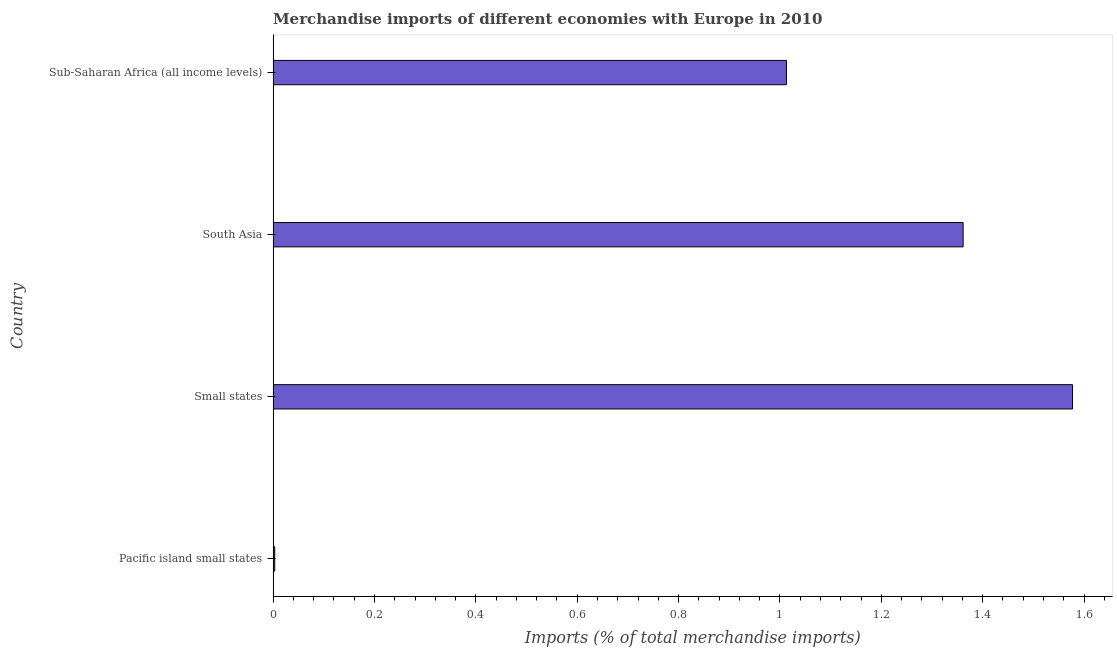Does the graph contain grids?
Make the answer very short. No. What is the title of the graph?
Make the answer very short. Merchandise imports of different economies with Europe in 2010. What is the label or title of the X-axis?
Give a very brief answer. Imports (% of total merchandise imports). What is the merchandise imports in Pacific island small states?
Offer a terse response. 0. Across all countries, what is the maximum merchandise imports?
Your response must be concise. 1.58. Across all countries, what is the minimum merchandise imports?
Offer a terse response. 0. In which country was the merchandise imports maximum?
Ensure brevity in your answer.  Small states. In which country was the merchandise imports minimum?
Offer a terse response. Pacific island small states. What is the sum of the merchandise imports?
Give a very brief answer. 3.95. What is the difference between the merchandise imports in Pacific island small states and South Asia?
Your response must be concise. -1.36. What is the median merchandise imports?
Give a very brief answer. 1.19. What is the ratio of the merchandise imports in Pacific island small states to that in Sub-Saharan Africa (all income levels)?
Make the answer very short. 0. Is the merchandise imports in Pacific island small states less than that in Sub-Saharan Africa (all income levels)?
Keep it short and to the point. Yes. What is the difference between the highest and the second highest merchandise imports?
Ensure brevity in your answer.  0.22. Is the sum of the merchandise imports in Small states and South Asia greater than the maximum merchandise imports across all countries?
Offer a terse response. Yes. What is the difference between the highest and the lowest merchandise imports?
Provide a short and direct response. 1.57. In how many countries, is the merchandise imports greater than the average merchandise imports taken over all countries?
Your answer should be very brief. 3. How many bars are there?
Provide a short and direct response. 4. What is the difference between two consecutive major ticks on the X-axis?
Make the answer very short. 0.2. Are the values on the major ticks of X-axis written in scientific E-notation?
Make the answer very short. No. What is the Imports (% of total merchandise imports) in Pacific island small states?
Your response must be concise. 0. What is the Imports (% of total merchandise imports) in Small states?
Make the answer very short. 1.58. What is the Imports (% of total merchandise imports) in South Asia?
Provide a succinct answer. 1.36. What is the Imports (% of total merchandise imports) of Sub-Saharan Africa (all income levels)?
Offer a terse response. 1.01. What is the difference between the Imports (% of total merchandise imports) in Pacific island small states and Small states?
Offer a very short reply. -1.57. What is the difference between the Imports (% of total merchandise imports) in Pacific island small states and South Asia?
Ensure brevity in your answer.  -1.36. What is the difference between the Imports (% of total merchandise imports) in Pacific island small states and Sub-Saharan Africa (all income levels)?
Offer a very short reply. -1.01. What is the difference between the Imports (% of total merchandise imports) in Small states and South Asia?
Your answer should be compact. 0.22. What is the difference between the Imports (% of total merchandise imports) in Small states and Sub-Saharan Africa (all income levels)?
Provide a succinct answer. 0.56. What is the difference between the Imports (% of total merchandise imports) in South Asia and Sub-Saharan Africa (all income levels)?
Your response must be concise. 0.35. What is the ratio of the Imports (% of total merchandise imports) in Pacific island small states to that in Small states?
Offer a very short reply. 0. What is the ratio of the Imports (% of total merchandise imports) in Pacific island small states to that in South Asia?
Your answer should be compact. 0. What is the ratio of the Imports (% of total merchandise imports) in Pacific island small states to that in Sub-Saharan Africa (all income levels)?
Your response must be concise. 0. What is the ratio of the Imports (% of total merchandise imports) in Small states to that in South Asia?
Offer a terse response. 1.16. What is the ratio of the Imports (% of total merchandise imports) in Small states to that in Sub-Saharan Africa (all income levels)?
Your answer should be compact. 1.56. What is the ratio of the Imports (% of total merchandise imports) in South Asia to that in Sub-Saharan Africa (all income levels)?
Keep it short and to the point. 1.34. 